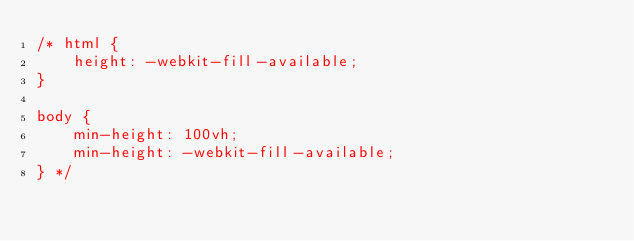Convert code to text. <code><loc_0><loc_0><loc_500><loc_500><_CSS_>/* html {
    height: -webkit-fill-available;
}

body {
    min-height: 100vh;
    min-height: -webkit-fill-available;
} */</code> 